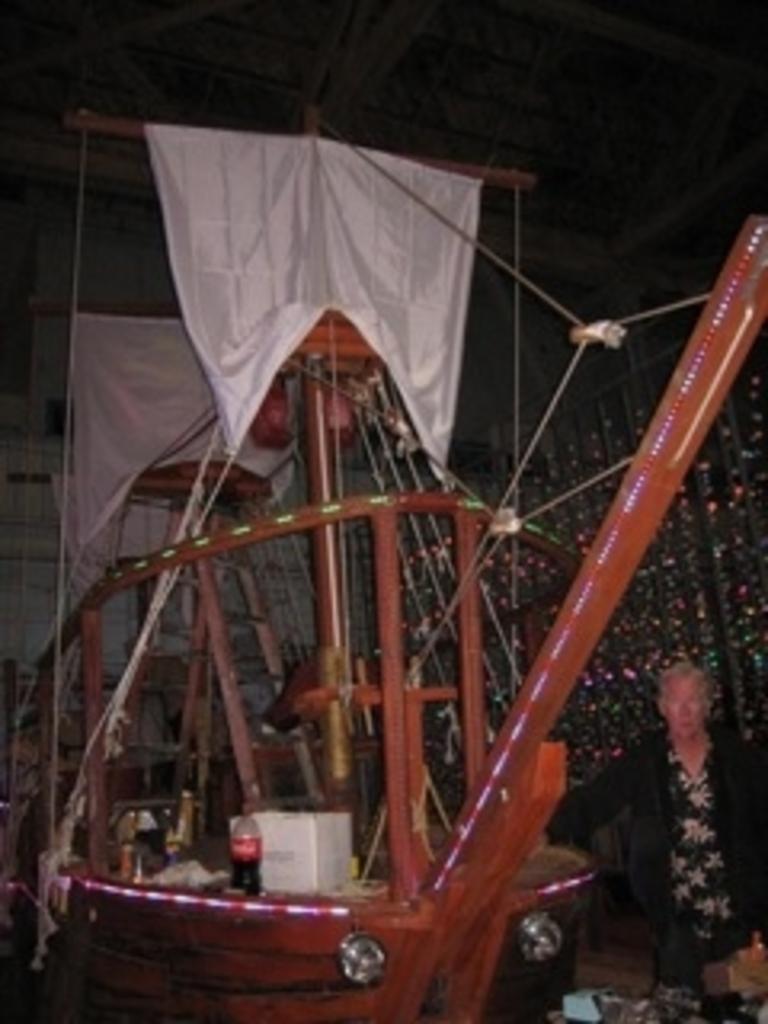Please provide a concise description of this image. This is the picture of a room. In this image there is a person standing beside the boat. There is a bottle and cardboard box on the boat. At the top there is a roof. There are lights on the boat. 